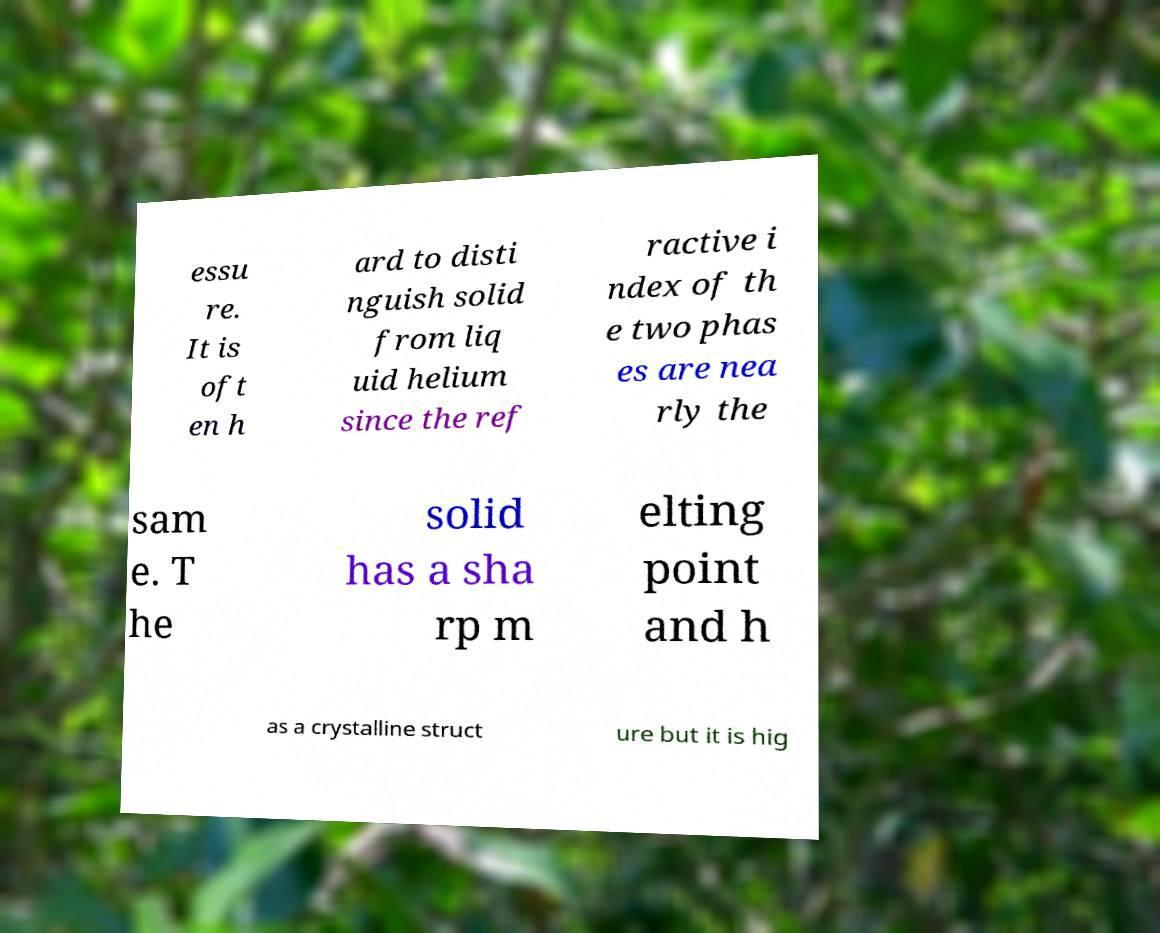There's text embedded in this image that I need extracted. Can you transcribe it verbatim? essu re. It is oft en h ard to disti nguish solid from liq uid helium since the ref ractive i ndex of th e two phas es are nea rly the sam e. T he solid has a sha rp m elting point and h as a crystalline struct ure but it is hig 